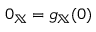Convert formula to latex. <formula><loc_0><loc_0><loc_500><loc_500>0 _ { \mathbb { X } } = g _ { \mathbb { X } } ( 0 )</formula> 